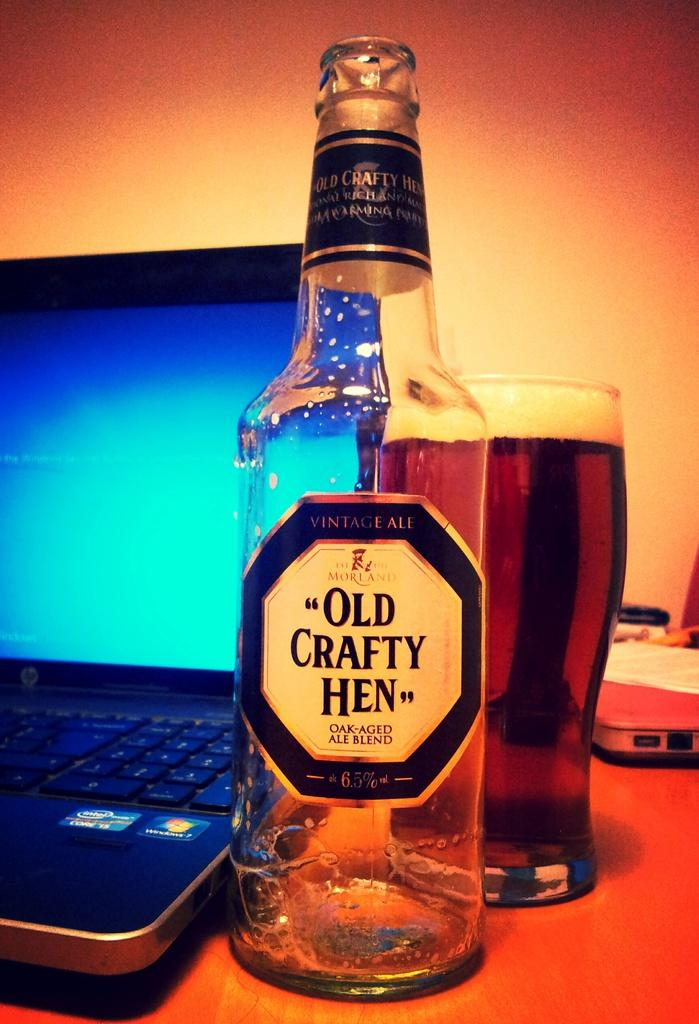Provide a one-sentence caption for the provided image. A laptop, a glass of beer and an "Old Crafty Hen" beer bottle. 